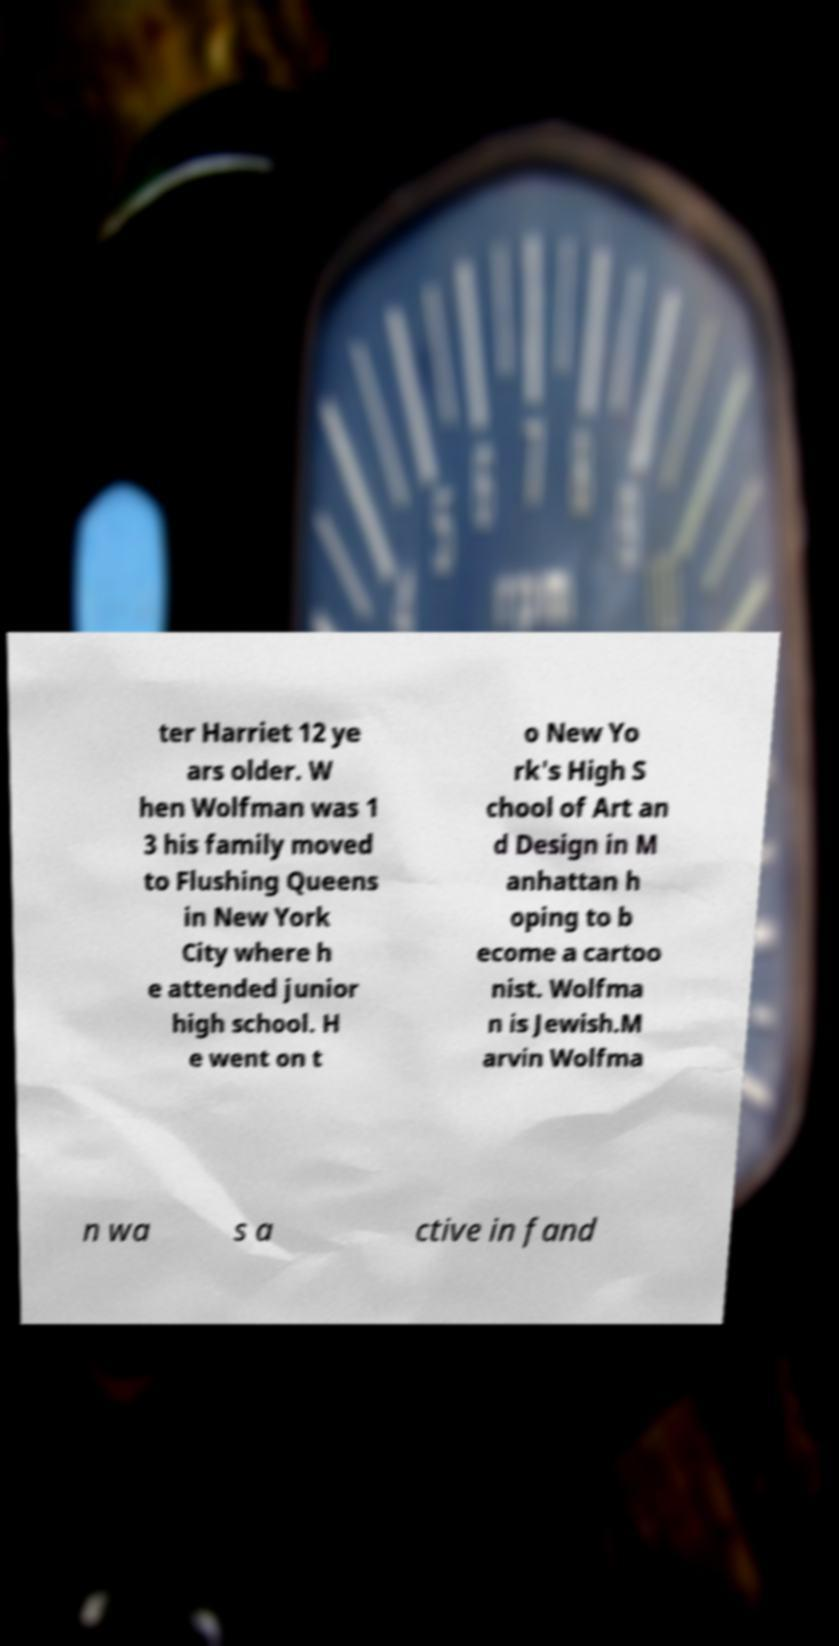Can you read and provide the text displayed in the image?This photo seems to have some interesting text. Can you extract and type it out for me? ter Harriet 12 ye ars older. W hen Wolfman was 1 3 his family moved to Flushing Queens in New York City where h e attended junior high school. H e went on t o New Yo rk's High S chool of Art an d Design in M anhattan h oping to b ecome a cartoo nist. Wolfma n is Jewish.M arvin Wolfma n wa s a ctive in fand 